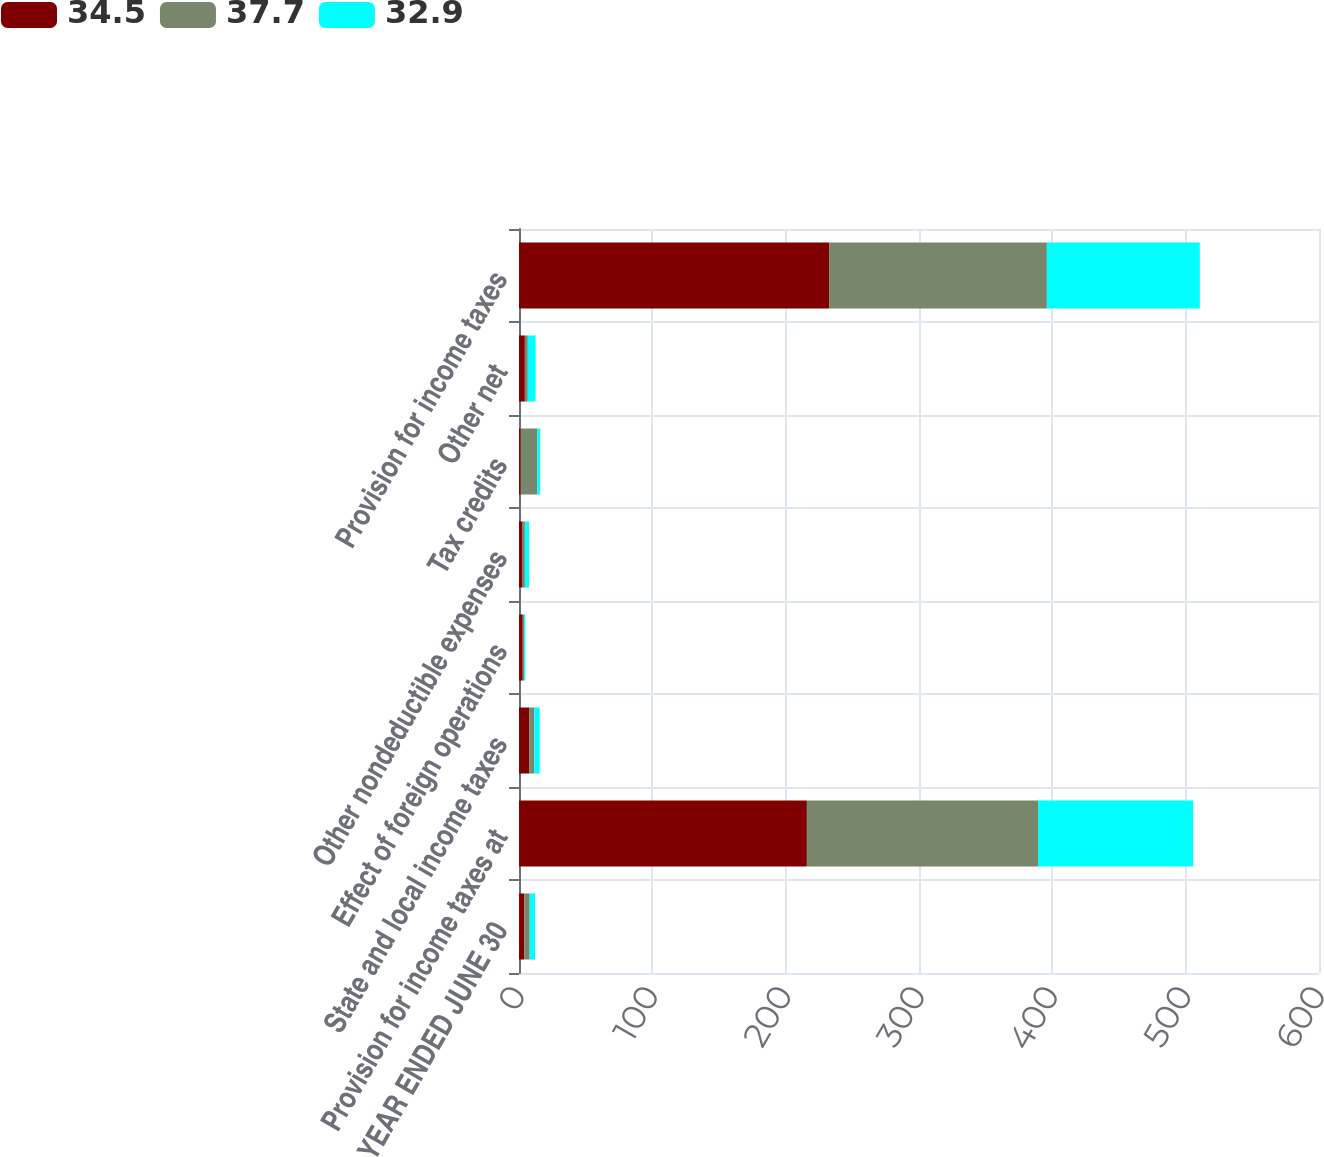Convert chart. <chart><loc_0><loc_0><loc_500><loc_500><stacked_bar_chart><ecel><fcel>YEAR ENDED JUNE 30<fcel>Provision for income taxes at<fcel>State and local income taxes<fcel>Effect of foreign operations<fcel>Other nondeductible expenses<fcel>Tax credits<fcel>Other net<fcel>Provision for income taxes<nl><fcel>34.5<fcel>4<fcel>215.9<fcel>7.6<fcel>2.8<fcel>2.7<fcel>1.3<fcel>4.4<fcel>232.6<nl><fcel>37.7<fcel>4<fcel>173.4<fcel>3.9<fcel>1<fcel>1.7<fcel>12.5<fcel>2.2<fcel>163.3<nl><fcel>32.9<fcel>4<fcel>116.3<fcel>4<fcel>0.9<fcel>3.2<fcel>2.1<fcel>5.8<fcel>114.7<nl></chart> 